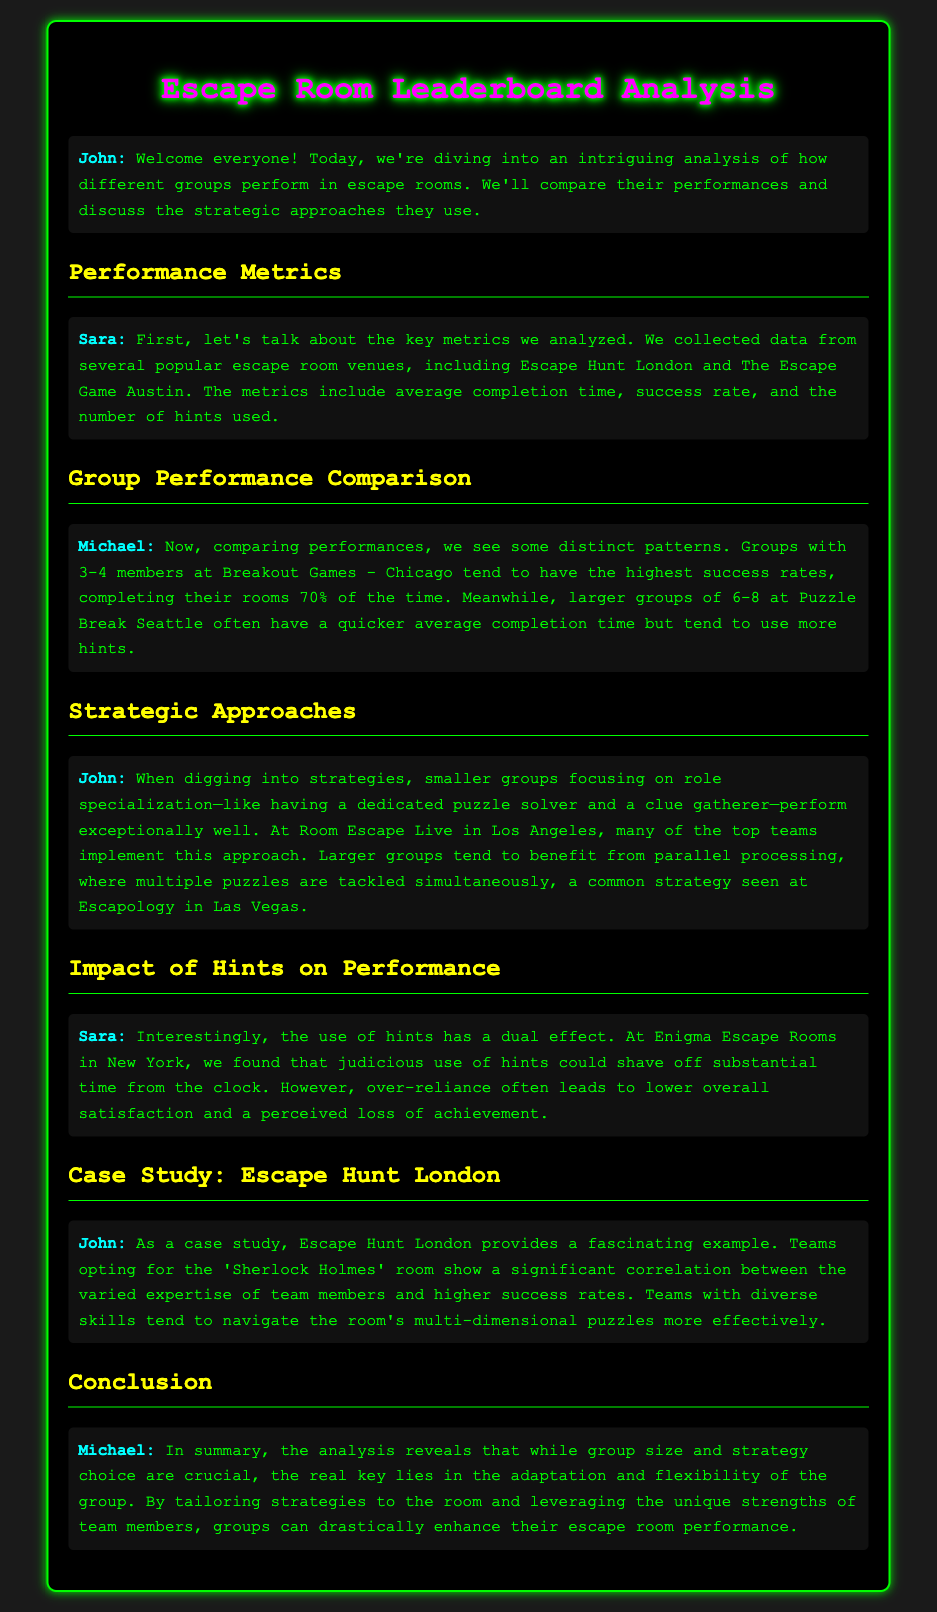What is the key focus of the analysis? The document discusses the comparison of group performances and strategic approaches in escape rooms.
Answer: Group performances and strategic approaches Which escape room venue has the highest success rate for groups of 3-4? The analysis indicates that Breakout Games in Chicago has the highest success rate for these group sizes.
Answer: Breakout Games - Chicago What is the average completion time trend for larger groups at Puzzle Break Seattle? Larger groups at Puzzle Break Seattle have a quicker average completion time but tend to use more hints.
Answer: Quicker average completion time What strategy do smaller groups at Room Escape Live in Los Angeles commonly use? Smaller groups often focus on role specialization to enhance performance.
Answer: Role specialization How does the use of hints affect performance at Enigma Escape Rooms in New York? The document mentions that judicious use of hints can save time, while over-reliance often decreases satisfaction.
Answer: Dual effect What correlation is highlighted in the case study on Escape Hunt London? The case study showcases a correlation between team member expertise variability and success rates.
Answer: Varied expertise of team members Who presented the conclusion of the analysis? The conclusion of the analysis is presented by Michael.
Answer: Michael 